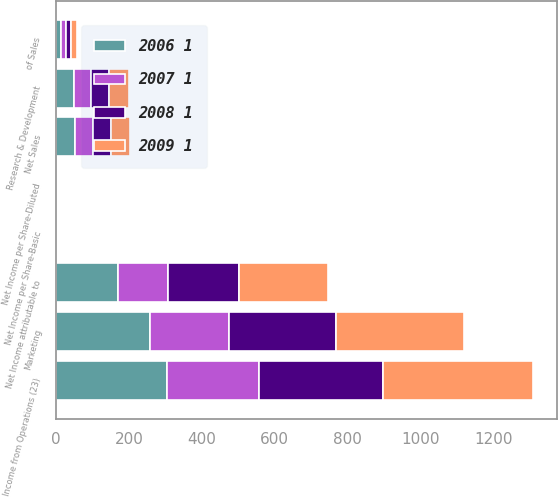Convert chart to OTSL. <chart><loc_0><loc_0><loc_500><loc_500><stacked_bar_chart><ecel><fcel>Net Sales<fcel>Marketing<fcel>Research & Development<fcel>Income from Operations (23)<fcel>of Sales<fcel>Net Income attributable to<fcel>Net Income per Share-Basic<fcel>Net Income per Share-Diluted<nl><fcel>2009 1<fcel>50.5<fcel>353.6<fcel>55.1<fcel>412.9<fcel>16.4<fcel>243.5<fcel>3.46<fcel>3.41<nl><fcel>2008 1<fcel>50.5<fcel>294.1<fcel>51.2<fcel>340.3<fcel>14.1<fcel>195.2<fcel>2.88<fcel>2.78<nl><fcel>2006 1<fcel>50.5<fcel>256.7<fcel>49.8<fcel>305<fcel>13.7<fcel>169<fcel>2.57<fcel>2.46<nl><fcel>2007 1<fcel>50.5<fcel>216.7<fcel>44.7<fcel>252.1<fcel>13<fcel>138.9<fcel>2.14<fcel>2.07<nl></chart> 